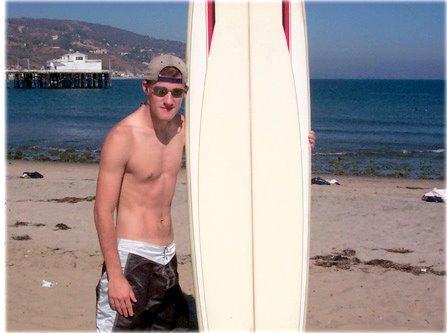How many trains are in the photo?
Give a very brief answer. 0. 